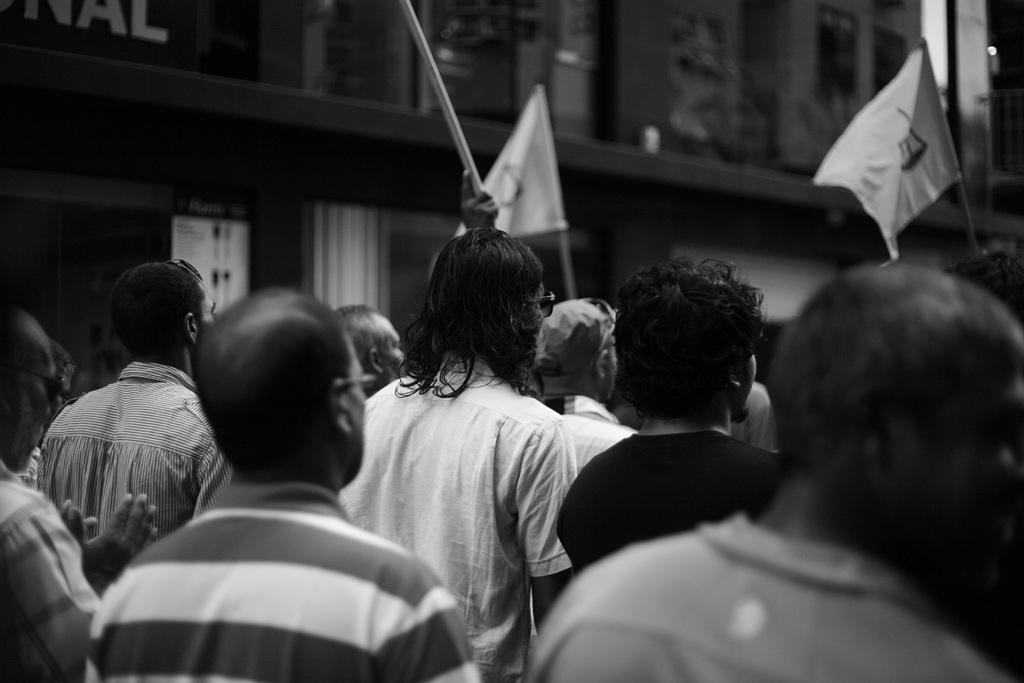What is the color scheme of the image? The image is black and white. What are the men in the front of the image doing? The men are standing in the front of the image and holding flags. What might be the reason for the men holding flags? The men appear to be protesting, which could be the reason for holding flags. What can be seen in the background of the image? There is a building visible in the background of the image. What type of orange is being used as a prop in the image? There is no orange present in the image; it is a black and white image with men holding flags and protesting. How does the fear of the protesters affect the outcome of the protest in the image? The image does not provide any information about the fear of the protesters or how it might affect the outcome of the protest. 